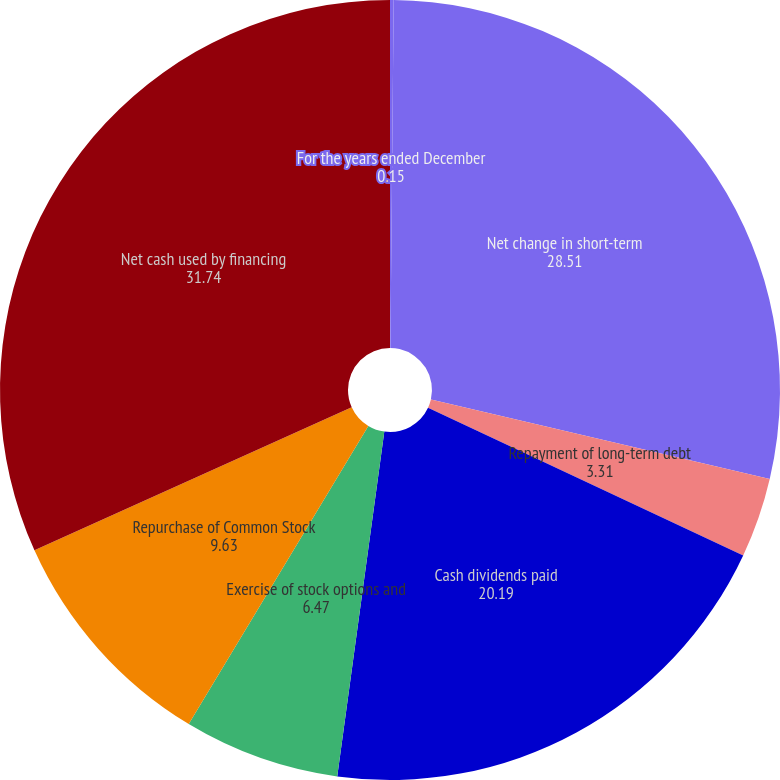Convert chart. <chart><loc_0><loc_0><loc_500><loc_500><pie_chart><fcel>For the years ended December<fcel>Net change in short-term<fcel>Repayment of long-term debt<fcel>Cash dividends paid<fcel>Exercise of stock options and<fcel>Repurchase of Common Stock<fcel>Net cash used by financing<nl><fcel>0.15%<fcel>28.51%<fcel>3.31%<fcel>20.19%<fcel>6.47%<fcel>9.63%<fcel>31.74%<nl></chart> 